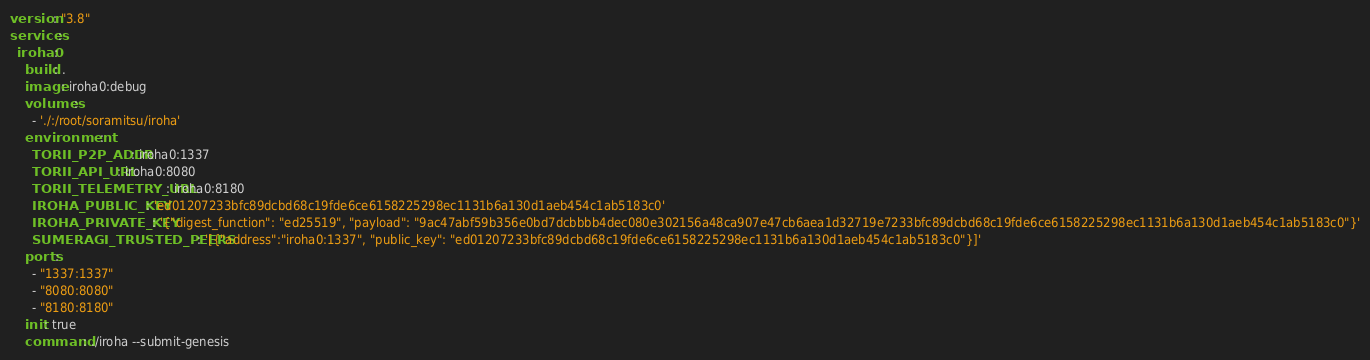Convert code to text. <code><loc_0><loc_0><loc_500><loc_500><_YAML_>version: "3.8"
services:
  iroha0:
    build: .
    image: iroha0:debug
    volumes:
      - './:/root/soramitsu/iroha'
    environment:
      TORII_P2P_ADDR: iroha0:1337
      TORII_API_URL: iroha0:8080
      TORII_TELEMETRY_URL: iroha0:8180
      IROHA_PUBLIC_KEY: 'ed01207233bfc89dcbd68c19fde6ce6158225298ec1131b6a130d1aeb454c1ab5183c0'
      IROHA_PRIVATE_KEY: '{"digest_function": "ed25519", "payload": "9ac47abf59b356e0bd7dcbbbb4dec080e302156a48ca907e47cb6aea1d32719e7233bfc89dcbd68c19fde6ce6158225298ec1131b6a130d1aeb454c1ab5183c0"}'
      SUMERAGI_TRUSTED_PEERS: '[{"address":"iroha0:1337", "public_key": "ed01207233bfc89dcbd68c19fde6ce6158225298ec1131b6a130d1aeb454c1ab5183c0"}]'
    ports:
      - "1337:1337"
      - "8080:8080"
      - "8180:8180"
    init: true
    command: ./iroha --submit-genesis
</code> 